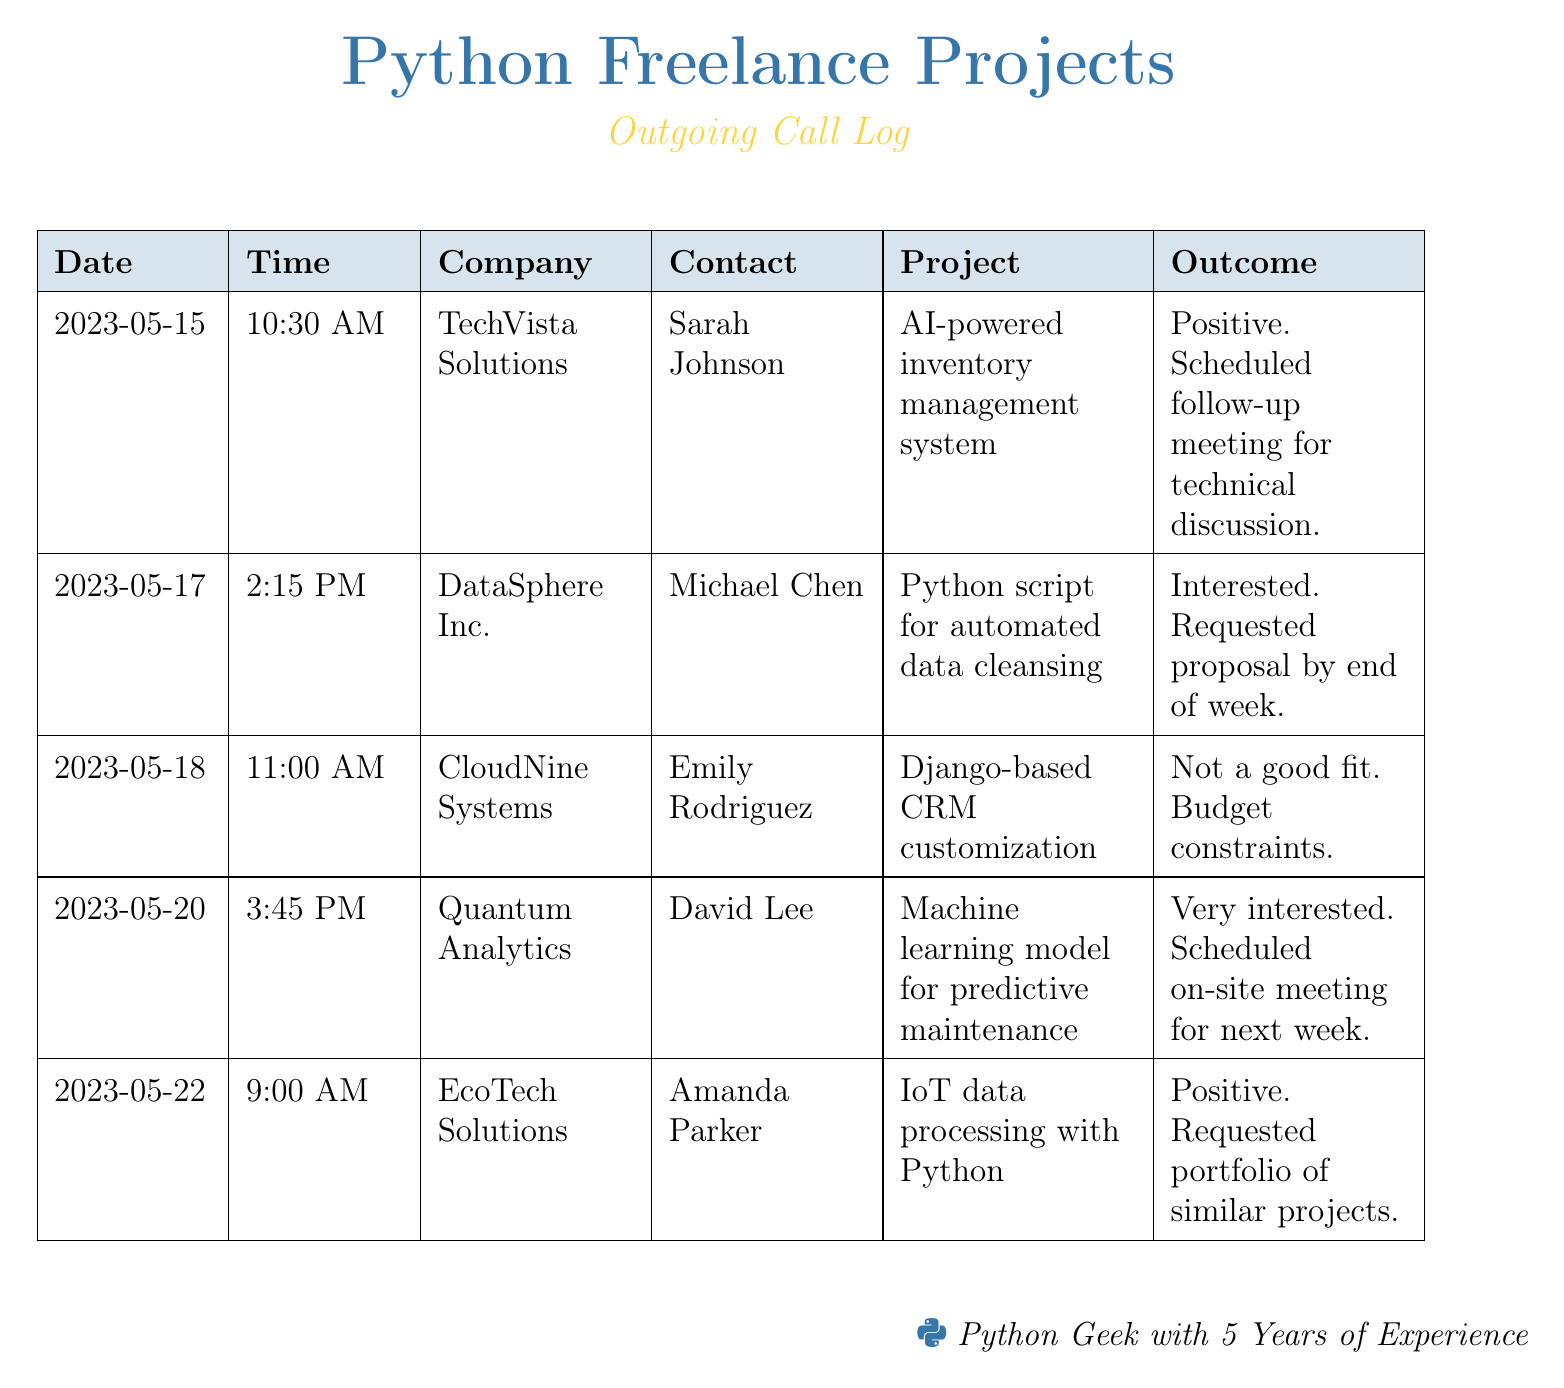What is the first company listed in the document? The first company listed is mentioned in the first row of the table.
Answer: TechVista Solutions Who is the contact person for Quantum Analytics? The contact person is listed in the row for Quantum Analytics.
Answer: David Lee On what date did the call to EcoTech Solutions occur? The date is mentioned in the row corresponding to EcoTech Solutions.
Answer: 2023-05-22 How many companies did the document log calls for? The document lists a total of 5 companies in the table.
Answer: 5 What outcome did the call with DataSphere Inc. yield? The outcome is specified in the row for DataSphere Inc.
Answer: Interested. Requested proposal by end of week Which project had a negative outcome? The project with a negative outcome is found in the row under CloudNine Systems.
Answer: Django-based CRM customization What time was the call to TechVista Solutions made? The time is noted in the row for TechVista Solutions.
Answer: 10:30 AM Which project is associated with Amanda Parker? The project is mentioned in the row assigned to EcoTech Solutions.
Answer: IoT data processing with Python 